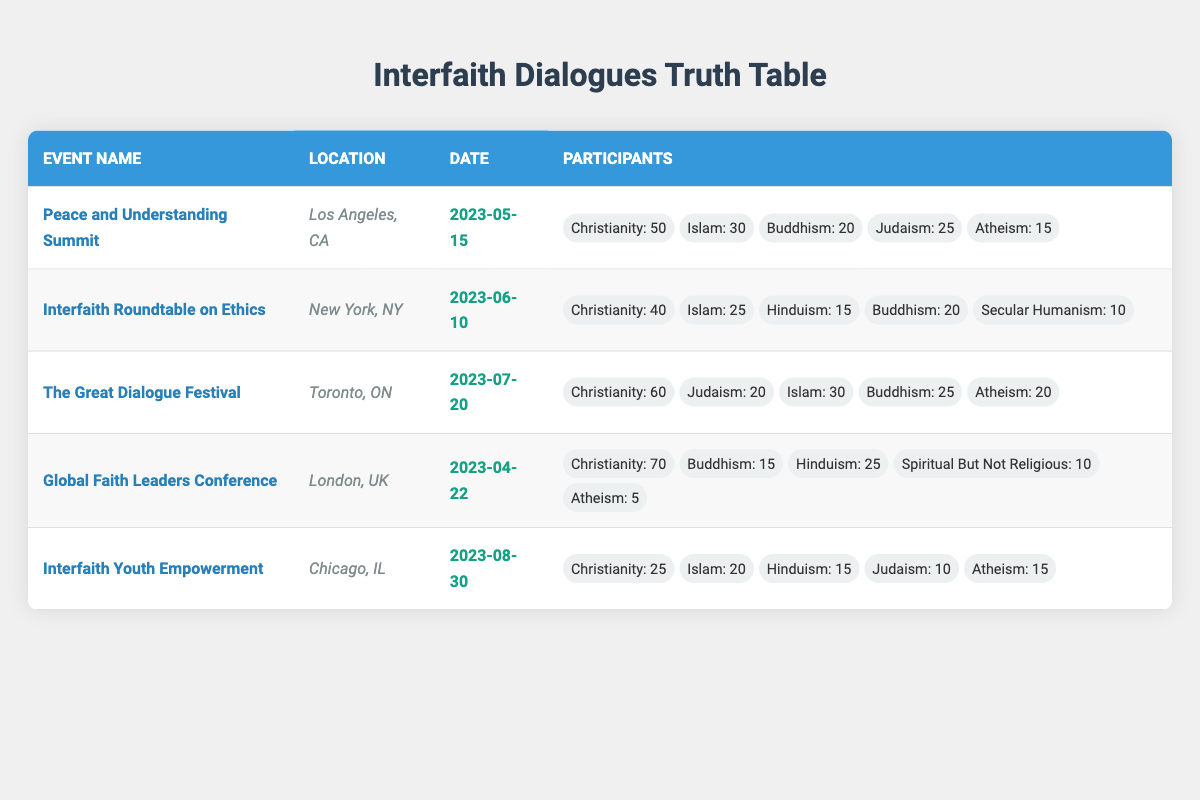What is the total number of participants at the "Peace and Understanding Summit"? To find the total participants, we need to add the numbers of participants from all belief systems involved: Christianity (50) + Islam (30) + Buddhism (20) + Judaism (25) + Atheism (15) = 140.
Answer: 140 Which event had the highest participation from Atheism? Looking through the data, the highest participation from Atheism is found in "The Great Dialogue Festival" with 20 participants.
Answer: 20 How many more Christians participated in the "Global Faith Leaders Conference" compared to the "Interfaith Youth Empowerment" event? The "Global Faith Leaders Conference" had 70 Christians, while the "Interfaith Youth Empowerment" had 25. We subtract the latter from the former: 70 - 25 = 45.
Answer: 45 Was there any event where Buddhism had more participants than Christianity? By examining the data, we can see that Buddhism never surpassed the number of participants from Christianity in any of the events listed, hence the answer is no.
Answer: No What is the average number of participants from Judaism across all events? There are three events with participants from Judaism: Peace and Understanding Summit (25), The Great Dialogue Festival (20), and Interfaith Youth Empowerment (10). We add them (25 + 20 + 10 = 55) and divide by 3 (55 / 3) to find the average, which is approximately 18.33.
Answer: 18.33 Which event had the least overall participation? By calculating total participants for each event, we find "Global Faith Leaders Conference" with 125 participants has the least overall participation. The calculations are: 140, 110, 155, 125, and 85 for each event respectively.
Answer: 85 Is there an event located in Los Angeles? Yes, the "Peace and Understanding Summit" is held in Los Angeles, CA, making the answer yes.
Answer: Yes How many participants attended events focused on Islam in total? Adding participants from all events that mention Islam: 30 (Peace and Understanding Summit) + 25 (Interfaith Roundtable on Ethics) + 30 (The Great Dialogue Festival) + 20 (Interfaith Youth Empowerment) gives a total of 105 participants from Islam across the events.
Answer: 105 